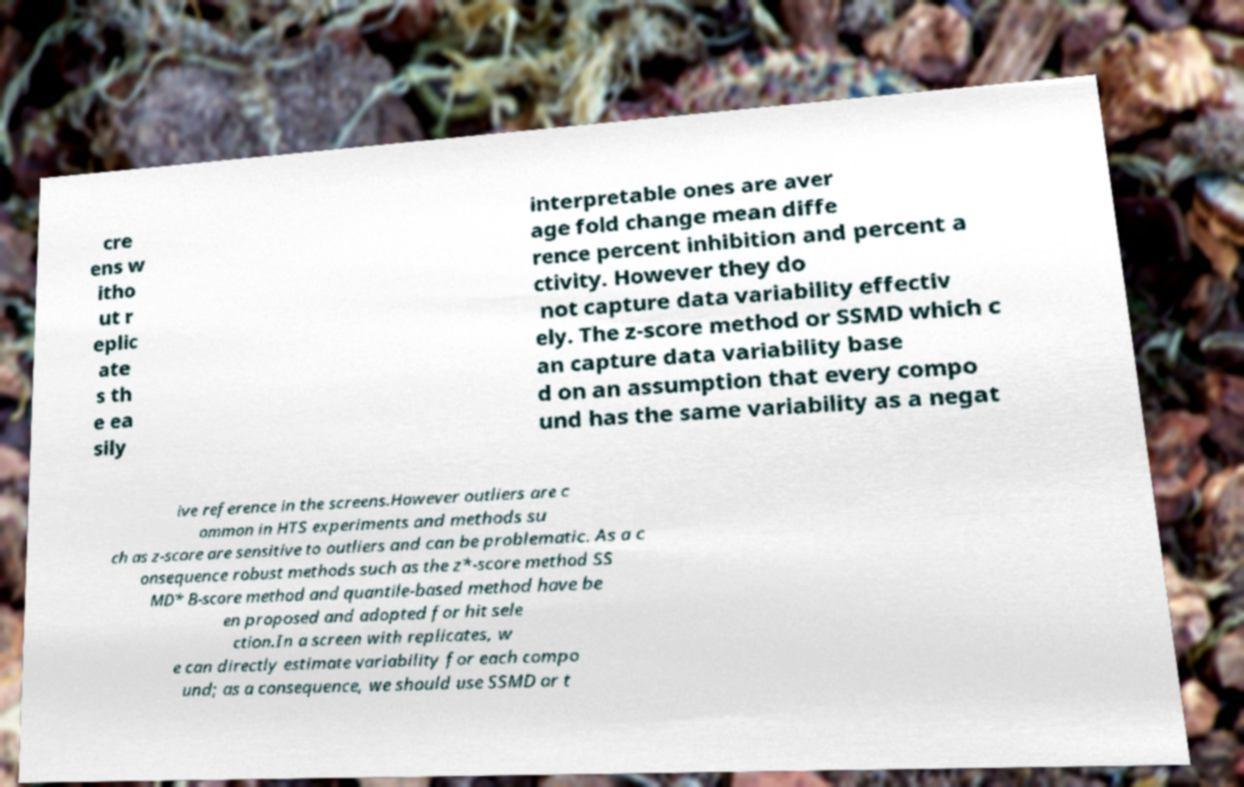Can you read and provide the text displayed in the image?This photo seems to have some interesting text. Can you extract and type it out for me? cre ens w itho ut r eplic ate s th e ea sily interpretable ones are aver age fold change mean diffe rence percent inhibition and percent a ctivity. However they do not capture data variability effectiv ely. The z-score method or SSMD which c an capture data variability base d on an assumption that every compo und has the same variability as a negat ive reference in the screens.However outliers are c ommon in HTS experiments and methods su ch as z-score are sensitive to outliers and can be problematic. As a c onsequence robust methods such as the z*-score method SS MD* B-score method and quantile-based method have be en proposed and adopted for hit sele ction.In a screen with replicates, w e can directly estimate variability for each compo und; as a consequence, we should use SSMD or t 